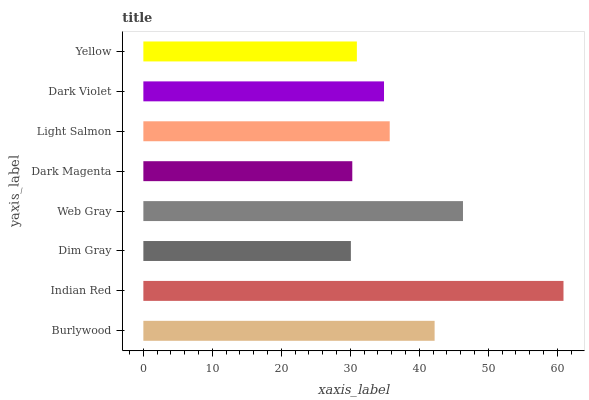Is Dim Gray the minimum?
Answer yes or no. Yes. Is Indian Red the maximum?
Answer yes or no. Yes. Is Indian Red the minimum?
Answer yes or no. No. Is Dim Gray the maximum?
Answer yes or no. No. Is Indian Red greater than Dim Gray?
Answer yes or no. Yes. Is Dim Gray less than Indian Red?
Answer yes or no. Yes. Is Dim Gray greater than Indian Red?
Answer yes or no. No. Is Indian Red less than Dim Gray?
Answer yes or no. No. Is Light Salmon the high median?
Answer yes or no. Yes. Is Dark Violet the low median?
Answer yes or no. Yes. Is Yellow the high median?
Answer yes or no. No. Is Burlywood the low median?
Answer yes or no. No. 